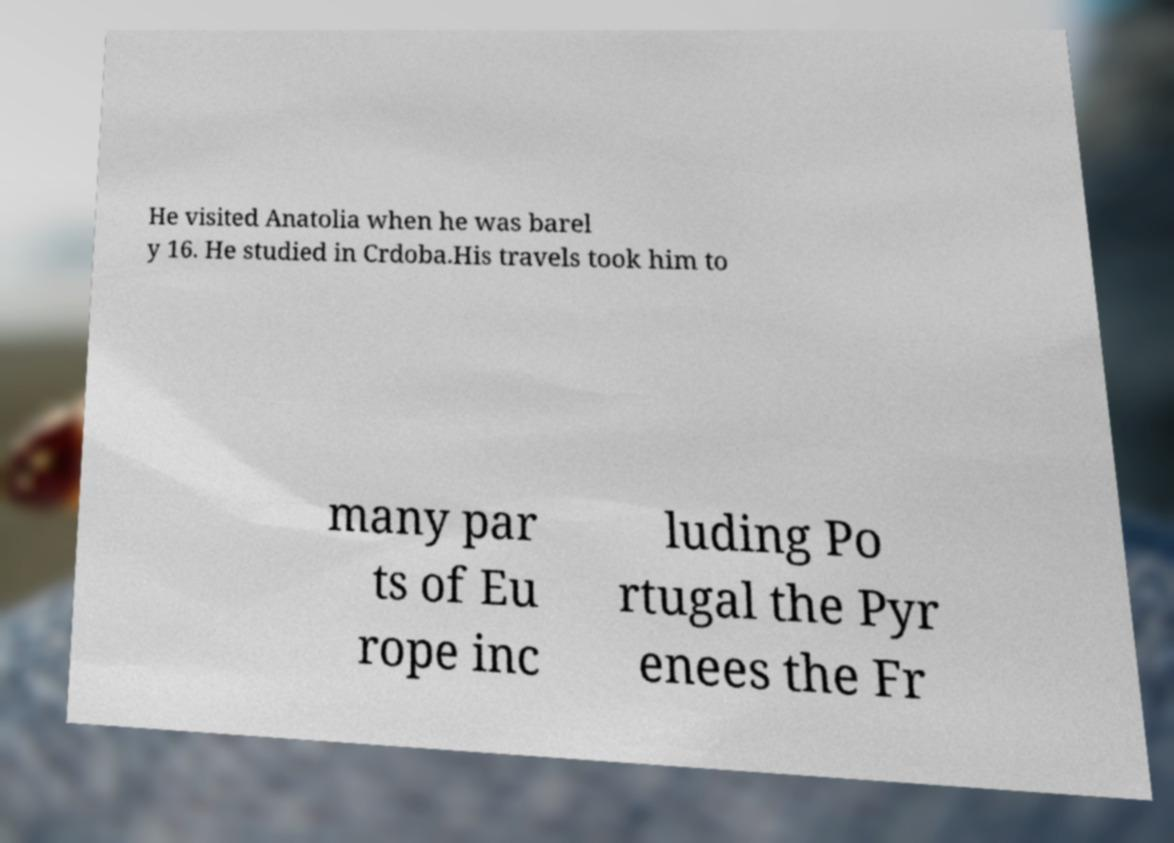Please identify and transcribe the text found in this image. He visited Anatolia when he was barel y 16. He studied in Crdoba.His travels took him to many par ts of Eu rope inc luding Po rtugal the Pyr enees the Fr 